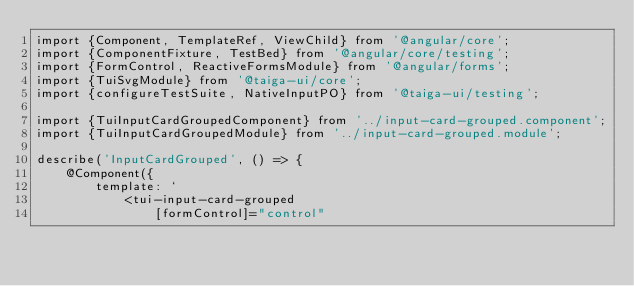<code> <loc_0><loc_0><loc_500><loc_500><_TypeScript_>import {Component, TemplateRef, ViewChild} from '@angular/core';
import {ComponentFixture, TestBed} from '@angular/core/testing';
import {FormControl, ReactiveFormsModule} from '@angular/forms';
import {TuiSvgModule} from '@taiga-ui/core';
import {configureTestSuite, NativeInputPO} from '@taiga-ui/testing';

import {TuiInputCardGroupedComponent} from '../input-card-grouped.component';
import {TuiInputCardGroupedModule} from '../input-card-grouped.module';

describe('InputCardGrouped', () => {
    @Component({
        template: `
            <tui-input-card-grouped
                [formControl]="control"</code> 